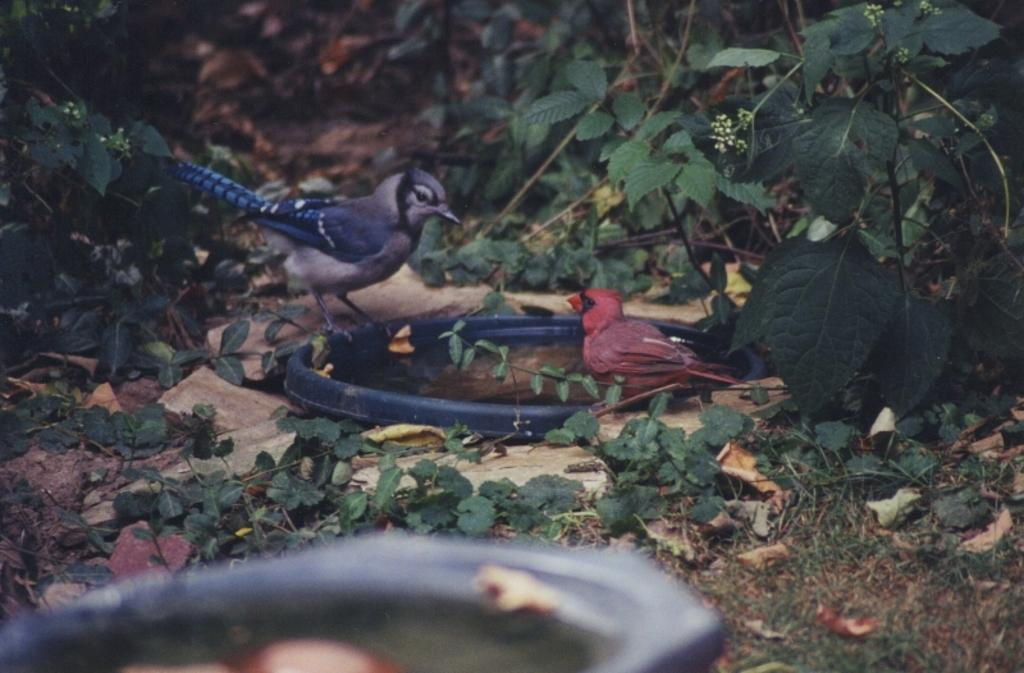How many birds are present in the image? There are two birds in the image. What colors are the birds? The birds are in blue and red colors. What are the birds standing on? The birds are standing on a blue color bowl. What can be seen in the background of the image? There are many trees visible in the image. What type of pan is being used to cook the birds in the image? There is no pan or cooking activity present in the image; it features two birds standing on a blue color bowl. What day of the week is it in the image? The day of the week is not mentioned or visible in the image. 